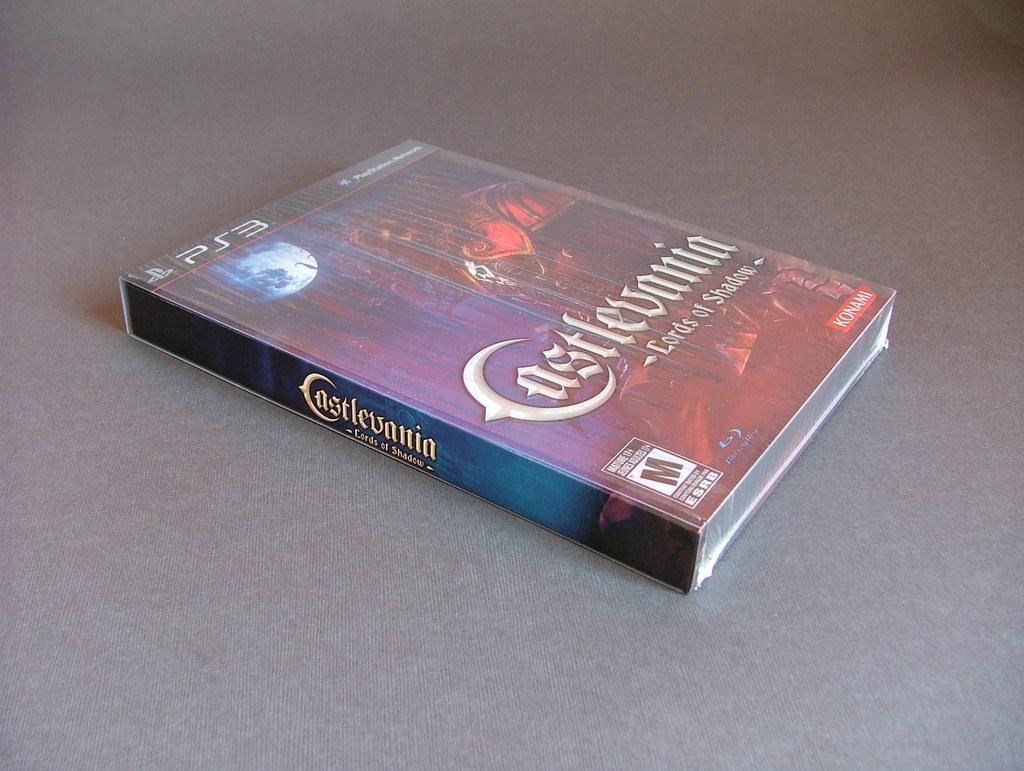<image>
Relay a brief, clear account of the picture shown. A movie game with the title Castlevania is for the PS3. 